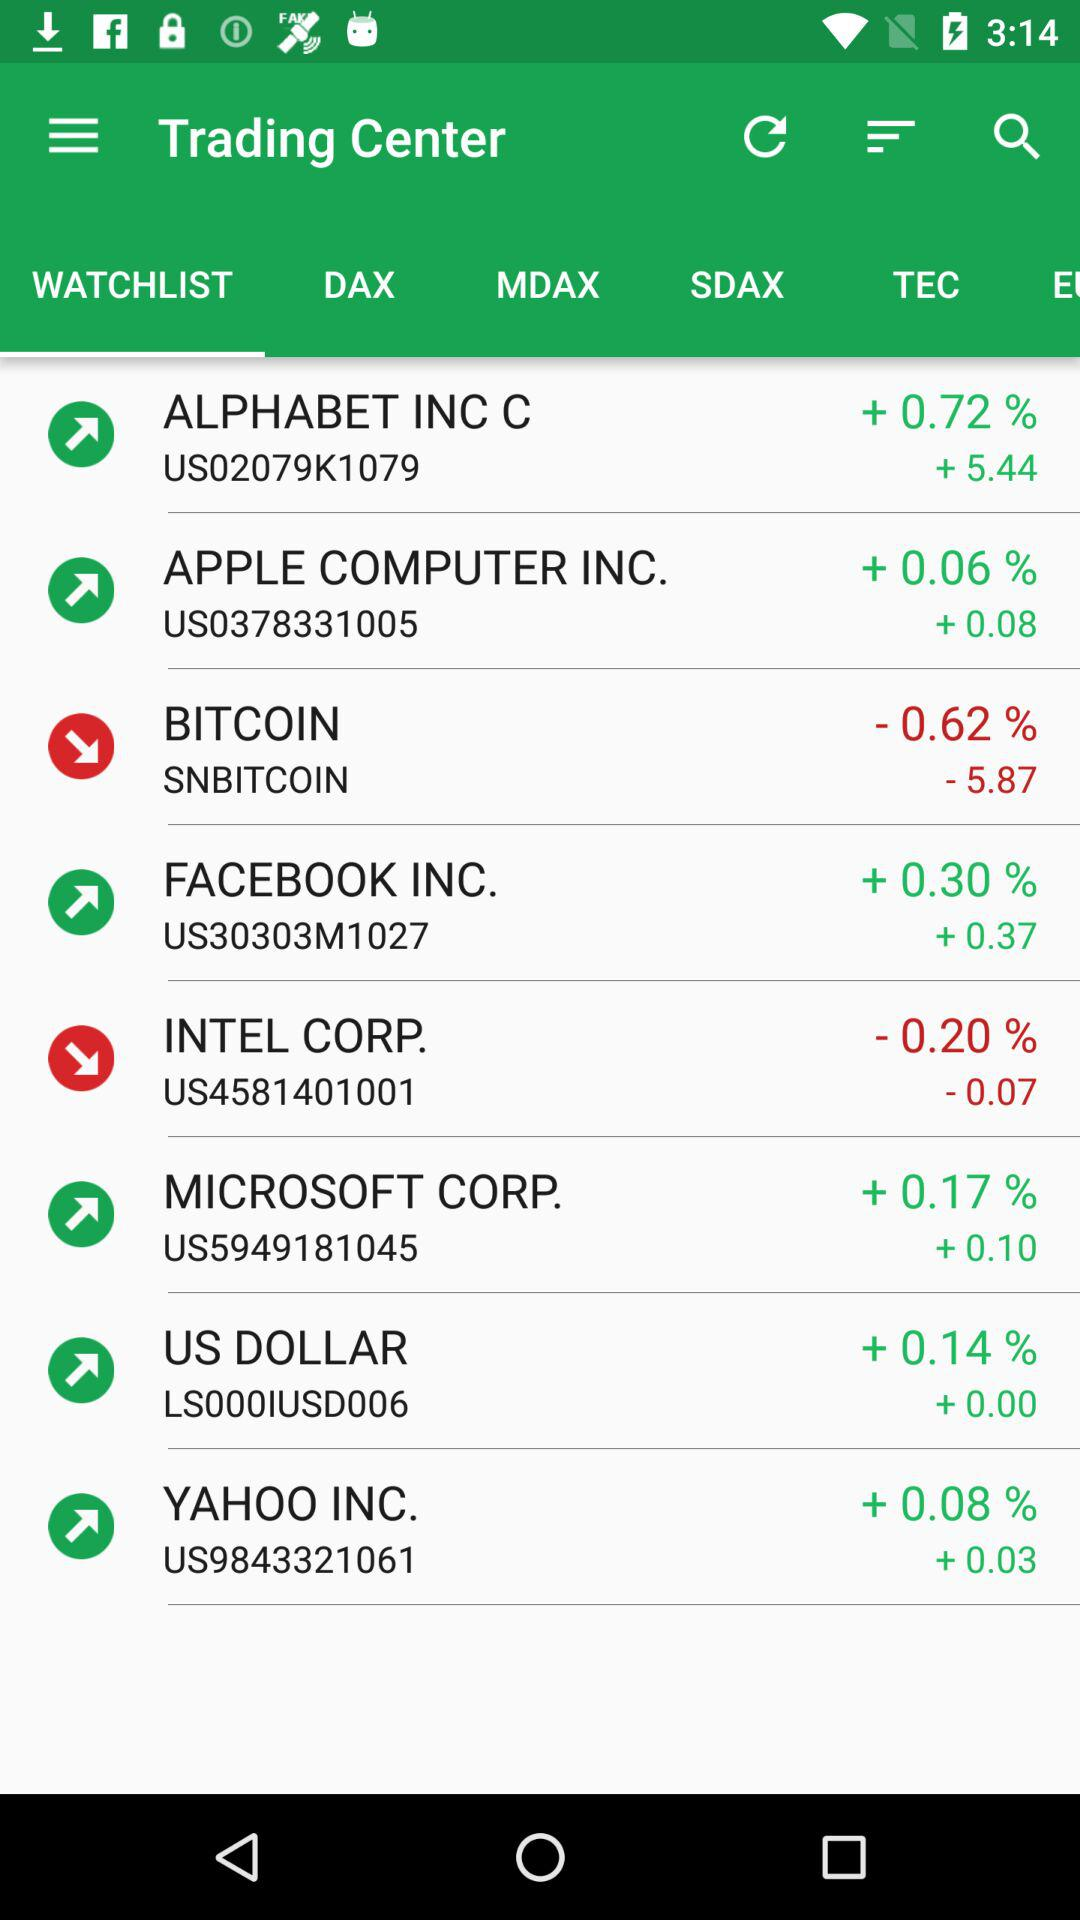Which tab is selected? The selected tab is "WATCHLIST". 